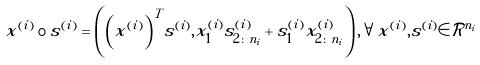<formula> <loc_0><loc_0><loc_500><loc_500>x ^ { ( i ) } \circ s ^ { ( i ) } = \left ( { \left ( x ^ { ( i ) } \right ) } ^ { T } s ^ { ( i ) } , x _ { 1 } ^ { ( i ) } s _ { 2 \colon n _ { i } } ^ { ( i ) } + s _ { 1 } ^ { ( i ) } x _ { 2 \colon n _ { i } } ^ { ( i ) } \right ) , \forall x ^ { ( i ) } , s ^ { ( i ) } \in \mathcal { R } ^ { n _ { i } }</formula> 